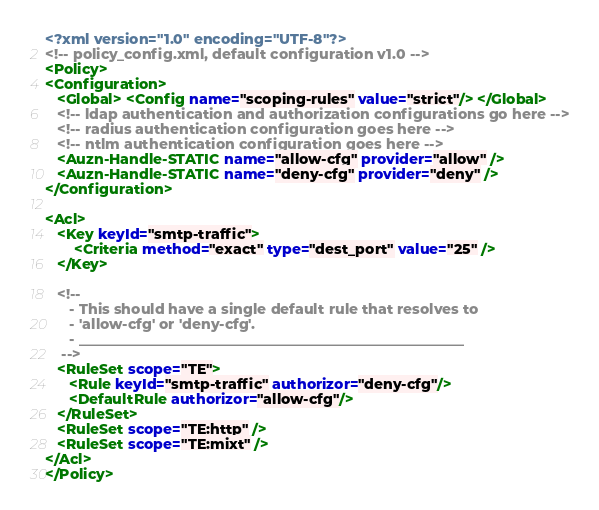<code> <loc_0><loc_0><loc_500><loc_500><_XML_><?xml version="1.0" encoding="UTF-8"?>
<!-- policy_config.xml, default configuration v1.0 -->
<Policy>
<Configuration>
   <Global> <Config name="scoping-rules" value="strict"/> </Global>
   <!-- ldap authentication and authorization configurations go here -->
   <!-- radius authentication configuration goes here -->
   <!-- ntlm authentication configuration goes here -->
   <Auzn-Handle-STATIC name="allow-cfg" provider="allow" />
   <Auzn-Handle-STATIC name="deny-cfg" provider="deny" />
</Configuration>

<Acl>
   <Key keyId="smtp-traffic">
       <Criteria method="exact" type="dest_port" value="25" />
   </Key>

   <!-- 
      - This should have a single default rule that resolves to
      - 'allow-cfg' or 'deny-cfg'.
      - _______________________________________________________
    -->
   <RuleSet scope="TE">
      <Rule keyId="smtp-traffic" authorizor="deny-cfg"/>
      <DefaultRule authorizor="allow-cfg"/>
   </RuleSet>
   <RuleSet scope="TE:http" />
   <RuleSet scope="TE:mixt" />
</Acl>
</Policy>
</code> 